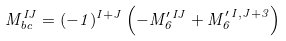Convert formula to latex. <formula><loc_0><loc_0><loc_500><loc_500>M ^ { I J } _ { b c } = ( - 1 ) ^ { I + J } \left ( - M ^ { \prime \, I J } _ { 6 } + M ^ { \prime \, I , J + 3 } _ { 6 } \right )</formula> 